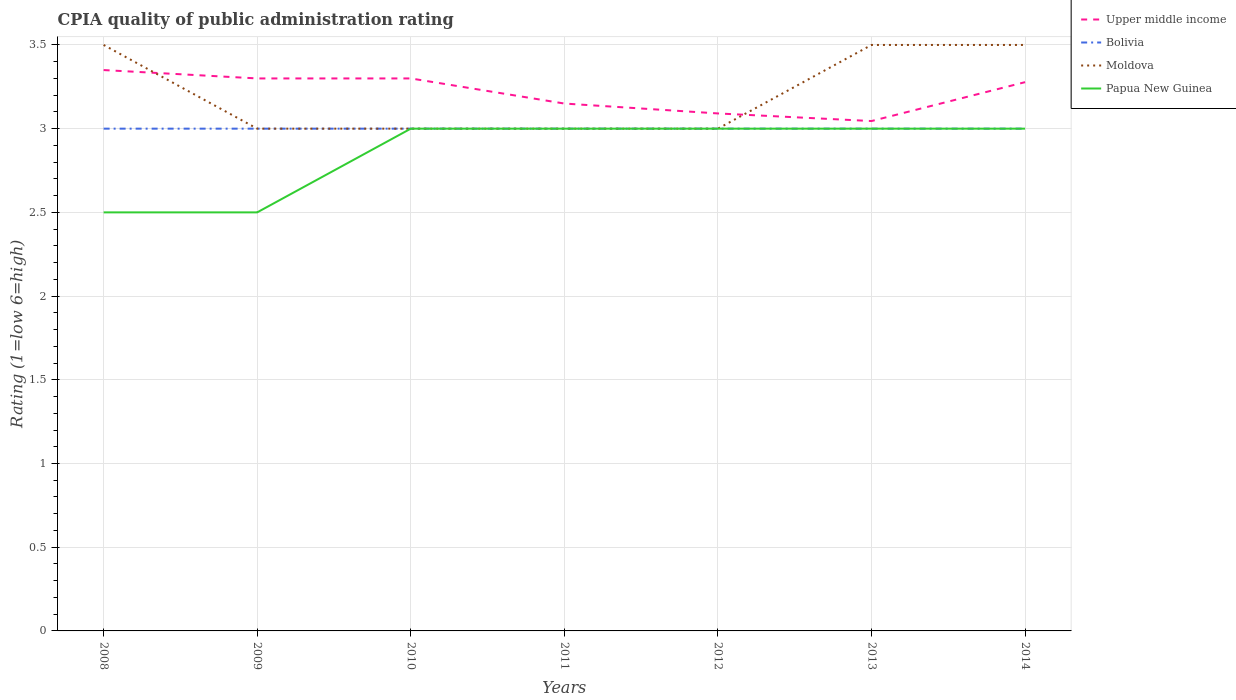Does the line corresponding to Papua New Guinea intersect with the line corresponding to Upper middle income?
Provide a short and direct response. No. In which year was the CPIA rating in Upper middle income maximum?
Keep it short and to the point. 2013. What is the difference between the highest and the second highest CPIA rating in Papua New Guinea?
Your answer should be compact. 0.5. What is the difference between the highest and the lowest CPIA rating in Upper middle income?
Provide a succinct answer. 4. Is the CPIA rating in Moldova strictly greater than the CPIA rating in Upper middle income over the years?
Your response must be concise. No. How many lines are there?
Make the answer very short. 4. How many years are there in the graph?
Give a very brief answer. 7. Does the graph contain any zero values?
Offer a very short reply. No. Does the graph contain grids?
Give a very brief answer. Yes. Where does the legend appear in the graph?
Ensure brevity in your answer.  Top right. How many legend labels are there?
Provide a succinct answer. 4. How are the legend labels stacked?
Your answer should be compact. Vertical. What is the title of the graph?
Provide a short and direct response. CPIA quality of public administration rating. What is the label or title of the X-axis?
Ensure brevity in your answer.  Years. What is the Rating (1=low 6=high) of Upper middle income in 2008?
Your answer should be very brief. 3.35. What is the Rating (1=low 6=high) of Bolivia in 2008?
Make the answer very short. 3. What is the Rating (1=low 6=high) of Moldova in 2008?
Ensure brevity in your answer.  3.5. What is the Rating (1=low 6=high) of Papua New Guinea in 2008?
Make the answer very short. 2.5. What is the Rating (1=low 6=high) of Upper middle income in 2009?
Offer a terse response. 3.3. What is the Rating (1=low 6=high) in Moldova in 2009?
Your answer should be compact. 3. What is the Rating (1=low 6=high) of Papua New Guinea in 2009?
Ensure brevity in your answer.  2.5. What is the Rating (1=low 6=high) of Upper middle income in 2010?
Your answer should be very brief. 3.3. What is the Rating (1=low 6=high) of Papua New Guinea in 2010?
Offer a terse response. 3. What is the Rating (1=low 6=high) in Upper middle income in 2011?
Keep it short and to the point. 3.15. What is the Rating (1=low 6=high) in Upper middle income in 2012?
Your answer should be very brief. 3.09. What is the Rating (1=low 6=high) in Moldova in 2012?
Your answer should be very brief. 3. What is the Rating (1=low 6=high) in Upper middle income in 2013?
Your response must be concise. 3.05. What is the Rating (1=low 6=high) of Upper middle income in 2014?
Keep it short and to the point. 3.28. What is the Rating (1=low 6=high) of Moldova in 2014?
Your answer should be compact. 3.5. What is the Rating (1=low 6=high) in Papua New Guinea in 2014?
Provide a succinct answer. 3. Across all years, what is the maximum Rating (1=low 6=high) of Upper middle income?
Ensure brevity in your answer.  3.35. Across all years, what is the maximum Rating (1=low 6=high) of Bolivia?
Offer a terse response. 3. Across all years, what is the maximum Rating (1=low 6=high) of Moldova?
Offer a very short reply. 3.5. Across all years, what is the minimum Rating (1=low 6=high) in Upper middle income?
Ensure brevity in your answer.  3.05. Across all years, what is the minimum Rating (1=low 6=high) in Bolivia?
Your answer should be compact. 3. Across all years, what is the minimum Rating (1=low 6=high) in Papua New Guinea?
Offer a very short reply. 2.5. What is the total Rating (1=low 6=high) of Upper middle income in the graph?
Make the answer very short. 22.51. What is the total Rating (1=low 6=high) of Bolivia in the graph?
Keep it short and to the point. 21. What is the total Rating (1=low 6=high) in Papua New Guinea in the graph?
Give a very brief answer. 20. What is the difference between the Rating (1=low 6=high) in Upper middle income in 2008 and that in 2009?
Provide a succinct answer. 0.05. What is the difference between the Rating (1=low 6=high) of Moldova in 2008 and that in 2009?
Keep it short and to the point. 0.5. What is the difference between the Rating (1=low 6=high) in Upper middle income in 2008 and that in 2010?
Offer a very short reply. 0.05. What is the difference between the Rating (1=low 6=high) of Bolivia in 2008 and that in 2010?
Provide a succinct answer. 0. What is the difference between the Rating (1=low 6=high) of Upper middle income in 2008 and that in 2011?
Offer a terse response. 0.2. What is the difference between the Rating (1=low 6=high) in Bolivia in 2008 and that in 2011?
Your answer should be very brief. 0. What is the difference between the Rating (1=low 6=high) in Upper middle income in 2008 and that in 2012?
Offer a terse response. 0.26. What is the difference between the Rating (1=low 6=high) of Bolivia in 2008 and that in 2012?
Provide a succinct answer. 0. What is the difference between the Rating (1=low 6=high) in Moldova in 2008 and that in 2012?
Offer a very short reply. 0.5. What is the difference between the Rating (1=low 6=high) in Upper middle income in 2008 and that in 2013?
Offer a terse response. 0.3. What is the difference between the Rating (1=low 6=high) in Bolivia in 2008 and that in 2013?
Offer a very short reply. 0. What is the difference between the Rating (1=low 6=high) in Papua New Guinea in 2008 and that in 2013?
Make the answer very short. -0.5. What is the difference between the Rating (1=low 6=high) of Upper middle income in 2008 and that in 2014?
Offer a terse response. 0.07. What is the difference between the Rating (1=low 6=high) of Moldova in 2008 and that in 2014?
Your response must be concise. 0. What is the difference between the Rating (1=low 6=high) of Bolivia in 2009 and that in 2010?
Ensure brevity in your answer.  0. What is the difference between the Rating (1=low 6=high) of Moldova in 2009 and that in 2010?
Ensure brevity in your answer.  0. What is the difference between the Rating (1=low 6=high) of Upper middle income in 2009 and that in 2011?
Provide a short and direct response. 0.15. What is the difference between the Rating (1=low 6=high) in Bolivia in 2009 and that in 2011?
Ensure brevity in your answer.  0. What is the difference between the Rating (1=low 6=high) of Papua New Guinea in 2009 and that in 2011?
Offer a very short reply. -0.5. What is the difference between the Rating (1=low 6=high) of Upper middle income in 2009 and that in 2012?
Offer a very short reply. 0.21. What is the difference between the Rating (1=low 6=high) of Bolivia in 2009 and that in 2012?
Give a very brief answer. 0. What is the difference between the Rating (1=low 6=high) of Moldova in 2009 and that in 2012?
Offer a terse response. 0. What is the difference between the Rating (1=low 6=high) of Upper middle income in 2009 and that in 2013?
Provide a succinct answer. 0.25. What is the difference between the Rating (1=low 6=high) of Moldova in 2009 and that in 2013?
Offer a very short reply. -0.5. What is the difference between the Rating (1=low 6=high) in Upper middle income in 2009 and that in 2014?
Your response must be concise. 0.02. What is the difference between the Rating (1=low 6=high) in Bolivia in 2009 and that in 2014?
Offer a very short reply. 0. What is the difference between the Rating (1=low 6=high) in Upper middle income in 2010 and that in 2012?
Provide a succinct answer. 0.21. What is the difference between the Rating (1=low 6=high) in Upper middle income in 2010 and that in 2013?
Keep it short and to the point. 0.25. What is the difference between the Rating (1=low 6=high) of Bolivia in 2010 and that in 2013?
Give a very brief answer. 0. What is the difference between the Rating (1=low 6=high) in Papua New Guinea in 2010 and that in 2013?
Your response must be concise. 0. What is the difference between the Rating (1=low 6=high) of Upper middle income in 2010 and that in 2014?
Provide a short and direct response. 0.02. What is the difference between the Rating (1=low 6=high) in Moldova in 2010 and that in 2014?
Offer a terse response. -0.5. What is the difference between the Rating (1=low 6=high) in Upper middle income in 2011 and that in 2012?
Offer a terse response. 0.06. What is the difference between the Rating (1=low 6=high) of Moldova in 2011 and that in 2012?
Provide a short and direct response. 0. What is the difference between the Rating (1=low 6=high) in Upper middle income in 2011 and that in 2013?
Your response must be concise. 0.1. What is the difference between the Rating (1=low 6=high) in Moldova in 2011 and that in 2013?
Make the answer very short. -0.5. What is the difference between the Rating (1=low 6=high) in Papua New Guinea in 2011 and that in 2013?
Offer a terse response. 0. What is the difference between the Rating (1=low 6=high) in Upper middle income in 2011 and that in 2014?
Keep it short and to the point. -0.13. What is the difference between the Rating (1=low 6=high) of Bolivia in 2011 and that in 2014?
Your answer should be compact. 0. What is the difference between the Rating (1=low 6=high) in Papua New Guinea in 2011 and that in 2014?
Offer a terse response. 0. What is the difference between the Rating (1=low 6=high) of Upper middle income in 2012 and that in 2013?
Your response must be concise. 0.05. What is the difference between the Rating (1=low 6=high) of Bolivia in 2012 and that in 2013?
Make the answer very short. 0. What is the difference between the Rating (1=low 6=high) in Upper middle income in 2012 and that in 2014?
Give a very brief answer. -0.19. What is the difference between the Rating (1=low 6=high) of Upper middle income in 2013 and that in 2014?
Your answer should be compact. -0.23. What is the difference between the Rating (1=low 6=high) in Upper middle income in 2008 and the Rating (1=low 6=high) in Moldova in 2009?
Provide a succinct answer. 0.35. What is the difference between the Rating (1=low 6=high) of Upper middle income in 2008 and the Rating (1=low 6=high) of Bolivia in 2010?
Provide a short and direct response. 0.35. What is the difference between the Rating (1=low 6=high) of Upper middle income in 2008 and the Rating (1=low 6=high) of Moldova in 2010?
Offer a very short reply. 0.35. What is the difference between the Rating (1=low 6=high) of Bolivia in 2008 and the Rating (1=low 6=high) of Moldova in 2010?
Your answer should be very brief. 0. What is the difference between the Rating (1=low 6=high) of Moldova in 2008 and the Rating (1=low 6=high) of Papua New Guinea in 2010?
Make the answer very short. 0.5. What is the difference between the Rating (1=low 6=high) of Upper middle income in 2008 and the Rating (1=low 6=high) of Bolivia in 2011?
Offer a terse response. 0.35. What is the difference between the Rating (1=low 6=high) in Upper middle income in 2008 and the Rating (1=low 6=high) in Papua New Guinea in 2011?
Make the answer very short. 0.35. What is the difference between the Rating (1=low 6=high) in Bolivia in 2008 and the Rating (1=low 6=high) in Moldova in 2011?
Offer a terse response. 0. What is the difference between the Rating (1=low 6=high) in Moldova in 2008 and the Rating (1=low 6=high) in Papua New Guinea in 2011?
Provide a short and direct response. 0.5. What is the difference between the Rating (1=low 6=high) of Bolivia in 2008 and the Rating (1=low 6=high) of Moldova in 2012?
Your answer should be compact. 0. What is the difference between the Rating (1=low 6=high) in Bolivia in 2008 and the Rating (1=low 6=high) in Papua New Guinea in 2012?
Provide a short and direct response. 0. What is the difference between the Rating (1=low 6=high) of Upper middle income in 2008 and the Rating (1=low 6=high) of Papua New Guinea in 2013?
Your answer should be very brief. 0.35. What is the difference between the Rating (1=low 6=high) in Bolivia in 2008 and the Rating (1=low 6=high) in Papua New Guinea in 2013?
Your response must be concise. 0. What is the difference between the Rating (1=low 6=high) in Upper middle income in 2008 and the Rating (1=low 6=high) in Papua New Guinea in 2014?
Keep it short and to the point. 0.35. What is the difference between the Rating (1=low 6=high) of Bolivia in 2008 and the Rating (1=low 6=high) of Papua New Guinea in 2014?
Provide a short and direct response. 0. What is the difference between the Rating (1=low 6=high) in Upper middle income in 2009 and the Rating (1=low 6=high) in Moldova in 2010?
Offer a very short reply. 0.3. What is the difference between the Rating (1=low 6=high) of Moldova in 2009 and the Rating (1=low 6=high) of Papua New Guinea in 2010?
Offer a terse response. 0. What is the difference between the Rating (1=low 6=high) of Upper middle income in 2009 and the Rating (1=low 6=high) of Papua New Guinea in 2011?
Provide a short and direct response. 0.3. What is the difference between the Rating (1=low 6=high) of Bolivia in 2009 and the Rating (1=low 6=high) of Moldova in 2011?
Keep it short and to the point. 0. What is the difference between the Rating (1=low 6=high) of Upper middle income in 2009 and the Rating (1=low 6=high) of Bolivia in 2012?
Make the answer very short. 0.3. What is the difference between the Rating (1=low 6=high) of Upper middle income in 2009 and the Rating (1=low 6=high) of Papua New Guinea in 2012?
Ensure brevity in your answer.  0.3. What is the difference between the Rating (1=low 6=high) in Bolivia in 2009 and the Rating (1=low 6=high) in Moldova in 2012?
Your response must be concise. 0. What is the difference between the Rating (1=low 6=high) of Upper middle income in 2009 and the Rating (1=low 6=high) of Moldova in 2013?
Ensure brevity in your answer.  -0.2. What is the difference between the Rating (1=low 6=high) in Bolivia in 2009 and the Rating (1=low 6=high) in Moldova in 2013?
Provide a succinct answer. -0.5. What is the difference between the Rating (1=low 6=high) in Bolivia in 2009 and the Rating (1=low 6=high) in Papua New Guinea in 2013?
Offer a very short reply. 0. What is the difference between the Rating (1=low 6=high) of Moldova in 2009 and the Rating (1=low 6=high) of Papua New Guinea in 2013?
Provide a succinct answer. 0. What is the difference between the Rating (1=low 6=high) in Upper middle income in 2009 and the Rating (1=low 6=high) in Moldova in 2014?
Offer a terse response. -0.2. What is the difference between the Rating (1=low 6=high) in Bolivia in 2009 and the Rating (1=low 6=high) in Papua New Guinea in 2014?
Your answer should be compact. 0. What is the difference between the Rating (1=low 6=high) of Upper middle income in 2010 and the Rating (1=low 6=high) of Moldova in 2011?
Give a very brief answer. 0.3. What is the difference between the Rating (1=low 6=high) of Bolivia in 2010 and the Rating (1=low 6=high) of Moldova in 2011?
Make the answer very short. 0. What is the difference between the Rating (1=low 6=high) of Moldova in 2010 and the Rating (1=low 6=high) of Papua New Guinea in 2011?
Make the answer very short. 0. What is the difference between the Rating (1=low 6=high) of Upper middle income in 2010 and the Rating (1=low 6=high) of Moldova in 2012?
Your answer should be compact. 0.3. What is the difference between the Rating (1=low 6=high) of Upper middle income in 2010 and the Rating (1=low 6=high) of Papua New Guinea in 2012?
Your answer should be compact. 0.3. What is the difference between the Rating (1=low 6=high) in Upper middle income in 2010 and the Rating (1=low 6=high) in Moldova in 2013?
Make the answer very short. -0.2. What is the difference between the Rating (1=low 6=high) in Upper middle income in 2010 and the Rating (1=low 6=high) in Papua New Guinea in 2013?
Offer a very short reply. 0.3. What is the difference between the Rating (1=low 6=high) in Bolivia in 2010 and the Rating (1=low 6=high) in Moldova in 2013?
Ensure brevity in your answer.  -0.5. What is the difference between the Rating (1=low 6=high) of Bolivia in 2010 and the Rating (1=low 6=high) of Papua New Guinea in 2013?
Ensure brevity in your answer.  0. What is the difference between the Rating (1=low 6=high) of Moldova in 2010 and the Rating (1=low 6=high) of Papua New Guinea in 2013?
Your response must be concise. 0. What is the difference between the Rating (1=low 6=high) in Upper middle income in 2010 and the Rating (1=low 6=high) in Moldova in 2014?
Provide a succinct answer. -0.2. What is the difference between the Rating (1=low 6=high) of Upper middle income in 2010 and the Rating (1=low 6=high) of Papua New Guinea in 2014?
Provide a succinct answer. 0.3. What is the difference between the Rating (1=low 6=high) of Moldova in 2010 and the Rating (1=low 6=high) of Papua New Guinea in 2014?
Keep it short and to the point. 0. What is the difference between the Rating (1=low 6=high) in Upper middle income in 2011 and the Rating (1=low 6=high) in Bolivia in 2012?
Your answer should be very brief. 0.15. What is the difference between the Rating (1=low 6=high) in Upper middle income in 2011 and the Rating (1=low 6=high) in Moldova in 2012?
Your answer should be compact. 0.15. What is the difference between the Rating (1=low 6=high) in Upper middle income in 2011 and the Rating (1=low 6=high) in Papua New Guinea in 2012?
Your response must be concise. 0.15. What is the difference between the Rating (1=low 6=high) of Upper middle income in 2011 and the Rating (1=low 6=high) of Bolivia in 2013?
Your answer should be very brief. 0.15. What is the difference between the Rating (1=low 6=high) in Upper middle income in 2011 and the Rating (1=low 6=high) in Moldova in 2013?
Your answer should be compact. -0.35. What is the difference between the Rating (1=low 6=high) of Upper middle income in 2011 and the Rating (1=low 6=high) of Papua New Guinea in 2013?
Your answer should be very brief. 0.15. What is the difference between the Rating (1=low 6=high) of Bolivia in 2011 and the Rating (1=low 6=high) of Moldova in 2013?
Offer a terse response. -0.5. What is the difference between the Rating (1=low 6=high) in Moldova in 2011 and the Rating (1=low 6=high) in Papua New Guinea in 2013?
Give a very brief answer. 0. What is the difference between the Rating (1=low 6=high) of Upper middle income in 2011 and the Rating (1=low 6=high) of Moldova in 2014?
Your answer should be very brief. -0.35. What is the difference between the Rating (1=low 6=high) in Upper middle income in 2011 and the Rating (1=low 6=high) in Papua New Guinea in 2014?
Provide a succinct answer. 0.15. What is the difference between the Rating (1=low 6=high) in Upper middle income in 2012 and the Rating (1=low 6=high) in Bolivia in 2013?
Provide a short and direct response. 0.09. What is the difference between the Rating (1=low 6=high) in Upper middle income in 2012 and the Rating (1=low 6=high) in Moldova in 2013?
Give a very brief answer. -0.41. What is the difference between the Rating (1=low 6=high) in Upper middle income in 2012 and the Rating (1=low 6=high) in Papua New Guinea in 2013?
Give a very brief answer. 0.09. What is the difference between the Rating (1=low 6=high) of Bolivia in 2012 and the Rating (1=low 6=high) of Moldova in 2013?
Make the answer very short. -0.5. What is the difference between the Rating (1=low 6=high) of Bolivia in 2012 and the Rating (1=low 6=high) of Papua New Guinea in 2013?
Provide a short and direct response. 0. What is the difference between the Rating (1=low 6=high) of Upper middle income in 2012 and the Rating (1=low 6=high) of Bolivia in 2014?
Your answer should be very brief. 0.09. What is the difference between the Rating (1=low 6=high) of Upper middle income in 2012 and the Rating (1=low 6=high) of Moldova in 2014?
Keep it short and to the point. -0.41. What is the difference between the Rating (1=low 6=high) of Upper middle income in 2012 and the Rating (1=low 6=high) of Papua New Guinea in 2014?
Your answer should be compact. 0.09. What is the difference between the Rating (1=low 6=high) of Bolivia in 2012 and the Rating (1=low 6=high) of Moldova in 2014?
Provide a short and direct response. -0.5. What is the difference between the Rating (1=low 6=high) in Upper middle income in 2013 and the Rating (1=low 6=high) in Bolivia in 2014?
Your answer should be compact. 0.05. What is the difference between the Rating (1=low 6=high) of Upper middle income in 2013 and the Rating (1=low 6=high) of Moldova in 2014?
Give a very brief answer. -0.45. What is the difference between the Rating (1=low 6=high) of Upper middle income in 2013 and the Rating (1=low 6=high) of Papua New Guinea in 2014?
Ensure brevity in your answer.  0.05. What is the difference between the Rating (1=low 6=high) of Moldova in 2013 and the Rating (1=low 6=high) of Papua New Guinea in 2014?
Give a very brief answer. 0.5. What is the average Rating (1=low 6=high) in Upper middle income per year?
Offer a very short reply. 3.22. What is the average Rating (1=low 6=high) of Moldova per year?
Ensure brevity in your answer.  3.21. What is the average Rating (1=low 6=high) of Papua New Guinea per year?
Provide a short and direct response. 2.86. In the year 2008, what is the difference between the Rating (1=low 6=high) in Bolivia and Rating (1=low 6=high) in Moldova?
Ensure brevity in your answer.  -0.5. In the year 2008, what is the difference between the Rating (1=low 6=high) of Bolivia and Rating (1=low 6=high) of Papua New Guinea?
Make the answer very short. 0.5. In the year 2009, what is the difference between the Rating (1=low 6=high) of Upper middle income and Rating (1=low 6=high) of Bolivia?
Make the answer very short. 0.3. In the year 2009, what is the difference between the Rating (1=low 6=high) in Upper middle income and Rating (1=low 6=high) in Papua New Guinea?
Keep it short and to the point. 0.8. In the year 2010, what is the difference between the Rating (1=low 6=high) in Upper middle income and Rating (1=low 6=high) in Bolivia?
Make the answer very short. 0.3. In the year 2010, what is the difference between the Rating (1=low 6=high) of Upper middle income and Rating (1=low 6=high) of Moldova?
Make the answer very short. 0.3. In the year 2010, what is the difference between the Rating (1=low 6=high) in Upper middle income and Rating (1=low 6=high) in Papua New Guinea?
Offer a very short reply. 0.3. In the year 2010, what is the difference between the Rating (1=low 6=high) in Bolivia and Rating (1=low 6=high) in Papua New Guinea?
Your answer should be compact. 0. In the year 2011, what is the difference between the Rating (1=low 6=high) of Bolivia and Rating (1=low 6=high) of Moldova?
Your response must be concise. 0. In the year 2011, what is the difference between the Rating (1=low 6=high) of Bolivia and Rating (1=low 6=high) of Papua New Guinea?
Give a very brief answer. 0. In the year 2012, what is the difference between the Rating (1=low 6=high) of Upper middle income and Rating (1=low 6=high) of Bolivia?
Keep it short and to the point. 0.09. In the year 2012, what is the difference between the Rating (1=low 6=high) in Upper middle income and Rating (1=low 6=high) in Moldova?
Your answer should be very brief. 0.09. In the year 2012, what is the difference between the Rating (1=low 6=high) in Upper middle income and Rating (1=low 6=high) in Papua New Guinea?
Provide a succinct answer. 0.09. In the year 2012, what is the difference between the Rating (1=low 6=high) in Bolivia and Rating (1=low 6=high) in Moldova?
Offer a terse response. 0. In the year 2012, what is the difference between the Rating (1=low 6=high) of Bolivia and Rating (1=low 6=high) of Papua New Guinea?
Offer a terse response. 0. In the year 2012, what is the difference between the Rating (1=low 6=high) of Moldova and Rating (1=low 6=high) of Papua New Guinea?
Your response must be concise. 0. In the year 2013, what is the difference between the Rating (1=low 6=high) in Upper middle income and Rating (1=low 6=high) in Bolivia?
Provide a short and direct response. 0.05. In the year 2013, what is the difference between the Rating (1=low 6=high) of Upper middle income and Rating (1=low 6=high) of Moldova?
Give a very brief answer. -0.45. In the year 2013, what is the difference between the Rating (1=low 6=high) of Upper middle income and Rating (1=low 6=high) of Papua New Guinea?
Your answer should be compact. 0.05. In the year 2013, what is the difference between the Rating (1=low 6=high) in Bolivia and Rating (1=low 6=high) in Moldova?
Your answer should be compact. -0.5. In the year 2013, what is the difference between the Rating (1=low 6=high) in Bolivia and Rating (1=low 6=high) in Papua New Guinea?
Make the answer very short. 0. In the year 2013, what is the difference between the Rating (1=low 6=high) in Moldova and Rating (1=low 6=high) in Papua New Guinea?
Offer a terse response. 0.5. In the year 2014, what is the difference between the Rating (1=low 6=high) of Upper middle income and Rating (1=low 6=high) of Bolivia?
Offer a very short reply. 0.28. In the year 2014, what is the difference between the Rating (1=low 6=high) in Upper middle income and Rating (1=low 6=high) in Moldova?
Ensure brevity in your answer.  -0.22. In the year 2014, what is the difference between the Rating (1=low 6=high) of Upper middle income and Rating (1=low 6=high) of Papua New Guinea?
Ensure brevity in your answer.  0.28. In the year 2014, what is the difference between the Rating (1=low 6=high) of Bolivia and Rating (1=low 6=high) of Moldova?
Keep it short and to the point. -0.5. What is the ratio of the Rating (1=low 6=high) in Upper middle income in 2008 to that in 2009?
Provide a succinct answer. 1.02. What is the ratio of the Rating (1=low 6=high) of Bolivia in 2008 to that in 2009?
Your answer should be compact. 1. What is the ratio of the Rating (1=low 6=high) in Moldova in 2008 to that in 2009?
Give a very brief answer. 1.17. What is the ratio of the Rating (1=low 6=high) of Papua New Guinea in 2008 to that in 2009?
Ensure brevity in your answer.  1. What is the ratio of the Rating (1=low 6=high) in Upper middle income in 2008 to that in 2010?
Your response must be concise. 1.02. What is the ratio of the Rating (1=low 6=high) in Upper middle income in 2008 to that in 2011?
Keep it short and to the point. 1.06. What is the ratio of the Rating (1=low 6=high) of Moldova in 2008 to that in 2011?
Offer a terse response. 1.17. What is the ratio of the Rating (1=low 6=high) in Papua New Guinea in 2008 to that in 2011?
Your answer should be very brief. 0.83. What is the ratio of the Rating (1=low 6=high) of Upper middle income in 2008 to that in 2012?
Make the answer very short. 1.08. What is the ratio of the Rating (1=low 6=high) of Bolivia in 2008 to that in 2012?
Provide a short and direct response. 1. What is the ratio of the Rating (1=low 6=high) of Moldova in 2008 to that in 2012?
Provide a short and direct response. 1.17. What is the ratio of the Rating (1=low 6=high) in Papua New Guinea in 2008 to that in 2012?
Offer a terse response. 0.83. What is the ratio of the Rating (1=low 6=high) in Bolivia in 2008 to that in 2013?
Provide a succinct answer. 1. What is the ratio of the Rating (1=low 6=high) in Papua New Guinea in 2008 to that in 2013?
Provide a succinct answer. 0.83. What is the ratio of the Rating (1=low 6=high) in Papua New Guinea in 2008 to that in 2014?
Your answer should be very brief. 0.83. What is the ratio of the Rating (1=low 6=high) of Moldova in 2009 to that in 2010?
Keep it short and to the point. 1. What is the ratio of the Rating (1=low 6=high) in Papua New Guinea in 2009 to that in 2010?
Your response must be concise. 0.83. What is the ratio of the Rating (1=low 6=high) in Upper middle income in 2009 to that in 2011?
Keep it short and to the point. 1.05. What is the ratio of the Rating (1=low 6=high) in Bolivia in 2009 to that in 2011?
Your response must be concise. 1. What is the ratio of the Rating (1=low 6=high) of Moldova in 2009 to that in 2011?
Keep it short and to the point. 1. What is the ratio of the Rating (1=low 6=high) in Papua New Guinea in 2009 to that in 2011?
Provide a succinct answer. 0.83. What is the ratio of the Rating (1=low 6=high) in Upper middle income in 2009 to that in 2012?
Give a very brief answer. 1.07. What is the ratio of the Rating (1=low 6=high) in Bolivia in 2009 to that in 2012?
Make the answer very short. 1. What is the ratio of the Rating (1=low 6=high) of Papua New Guinea in 2009 to that in 2012?
Provide a short and direct response. 0.83. What is the ratio of the Rating (1=low 6=high) of Upper middle income in 2009 to that in 2013?
Offer a terse response. 1.08. What is the ratio of the Rating (1=low 6=high) in Bolivia in 2009 to that in 2013?
Ensure brevity in your answer.  1. What is the ratio of the Rating (1=low 6=high) in Moldova in 2009 to that in 2013?
Make the answer very short. 0.86. What is the ratio of the Rating (1=low 6=high) in Papua New Guinea in 2009 to that in 2013?
Your answer should be very brief. 0.83. What is the ratio of the Rating (1=low 6=high) of Upper middle income in 2009 to that in 2014?
Make the answer very short. 1.01. What is the ratio of the Rating (1=low 6=high) of Upper middle income in 2010 to that in 2011?
Ensure brevity in your answer.  1.05. What is the ratio of the Rating (1=low 6=high) of Bolivia in 2010 to that in 2011?
Ensure brevity in your answer.  1. What is the ratio of the Rating (1=low 6=high) of Moldova in 2010 to that in 2011?
Offer a very short reply. 1. What is the ratio of the Rating (1=low 6=high) in Papua New Guinea in 2010 to that in 2011?
Offer a very short reply. 1. What is the ratio of the Rating (1=low 6=high) of Upper middle income in 2010 to that in 2012?
Your answer should be very brief. 1.07. What is the ratio of the Rating (1=low 6=high) in Bolivia in 2010 to that in 2012?
Your response must be concise. 1. What is the ratio of the Rating (1=low 6=high) in Moldova in 2010 to that in 2012?
Offer a terse response. 1. What is the ratio of the Rating (1=low 6=high) in Papua New Guinea in 2010 to that in 2012?
Make the answer very short. 1. What is the ratio of the Rating (1=low 6=high) of Upper middle income in 2010 to that in 2013?
Give a very brief answer. 1.08. What is the ratio of the Rating (1=low 6=high) in Moldova in 2010 to that in 2013?
Your response must be concise. 0.86. What is the ratio of the Rating (1=low 6=high) of Papua New Guinea in 2010 to that in 2013?
Make the answer very short. 1. What is the ratio of the Rating (1=low 6=high) of Upper middle income in 2010 to that in 2014?
Provide a succinct answer. 1.01. What is the ratio of the Rating (1=low 6=high) in Moldova in 2010 to that in 2014?
Keep it short and to the point. 0.86. What is the ratio of the Rating (1=low 6=high) in Papua New Guinea in 2010 to that in 2014?
Give a very brief answer. 1. What is the ratio of the Rating (1=low 6=high) in Upper middle income in 2011 to that in 2012?
Ensure brevity in your answer.  1.02. What is the ratio of the Rating (1=low 6=high) of Bolivia in 2011 to that in 2012?
Provide a short and direct response. 1. What is the ratio of the Rating (1=low 6=high) in Moldova in 2011 to that in 2012?
Provide a short and direct response. 1. What is the ratio of the Rating (1=low 6=high) in Upper middle income in 2011 to that in 2013?
Keep it short and to the point. 1.03. What is the ratio of the Rating (1=low 6=high) of Bolivia in 2011 to that in 2013?
Your answer should be compact. 1. What is the ratio of the Rating (1=low 6=high) of Moldova in 2011 to that in 2013?
Provide a short and direct response. 0.86. What is the ratio of the Rating (1=low 6=high) in Upper middle income in 2011 to that in 2014?
Offer a terse response. 0.96. What is the ratio of the Rating (1=low 6=high) in Moldova in 2011 to that in 2014?
Offer a terse response. 0.86. What is the ratio of the Rating (1=low 6=high) of Upper middle income in 2012 to that in 2013?
Ensure brevity in your answer.  1.01. What is the ratio of the Rating (1=low 6=high) of Moldova in 2012 to that in 2013?
Your answer should be compact. 0.86. What is the ratio of the Rating (1=low 6=high) of Upper middle income in 2012 to that in 2014?
Provide a succinct answer. 0.94. What is the ratio of the Rating (1=low 6=high) of Bolivia in 2012 to that in 2014?
Offer a very short reply. 1. What is the ratio of the Rating (1=low 6=high) in Papua New Guinea in 2012 to that in 2014?
Your response must be concise. 1. What is the ratio of the Rating (1=low 6=high) in Upper middle income in 2013 to that in 2014?
Your answer should be compact. 0.93. What is the ratio of the Rating (1=low 6=high) in Moldova in 2013 to that in 2014?
Offer a terse response. 1. What is the ratio of the Rating (1=low 6=high) of Papua New Guinea in 2013 to that in 2014?
Ensure brevity in your answer.  1. What is the difference between the highest and the second highest Rating (1=low 6=high) in Papua New Guinea?
Your answer should be compact. 0. What is the difference between the highest and the lowest Rating (1=low 6=high) of Upper middle income?
Offer a terse response. 0.3. What is the difference between the highest and the lowest Rating (1=low 6=high) in Bolivia?
Provide a short and direct response. 0. What is the difference between the highest and the lowest Rating (1=low 6=high) of Moldova?
Your answer should be compact. 0.5. What is the difference between the highest and the lowest Rating (1=low 6=high) of Papua New Guinea?
Make the answer very short. 0.5. 